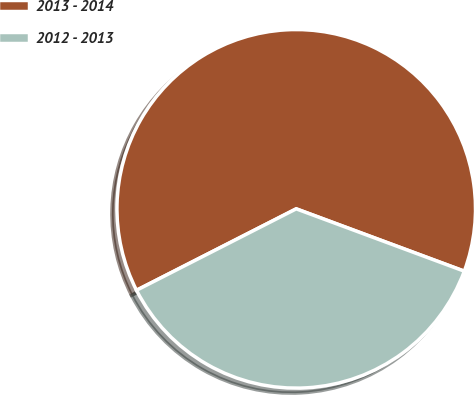Convert chart to OTSL. <chart><loc_0><loc_0><loc_500><loc_500><pie_chart><fcel>2013 - 2014<fcel>2012 - 2013<nl><fcel>63.16%<fcel>36.84%<nl></chart> 